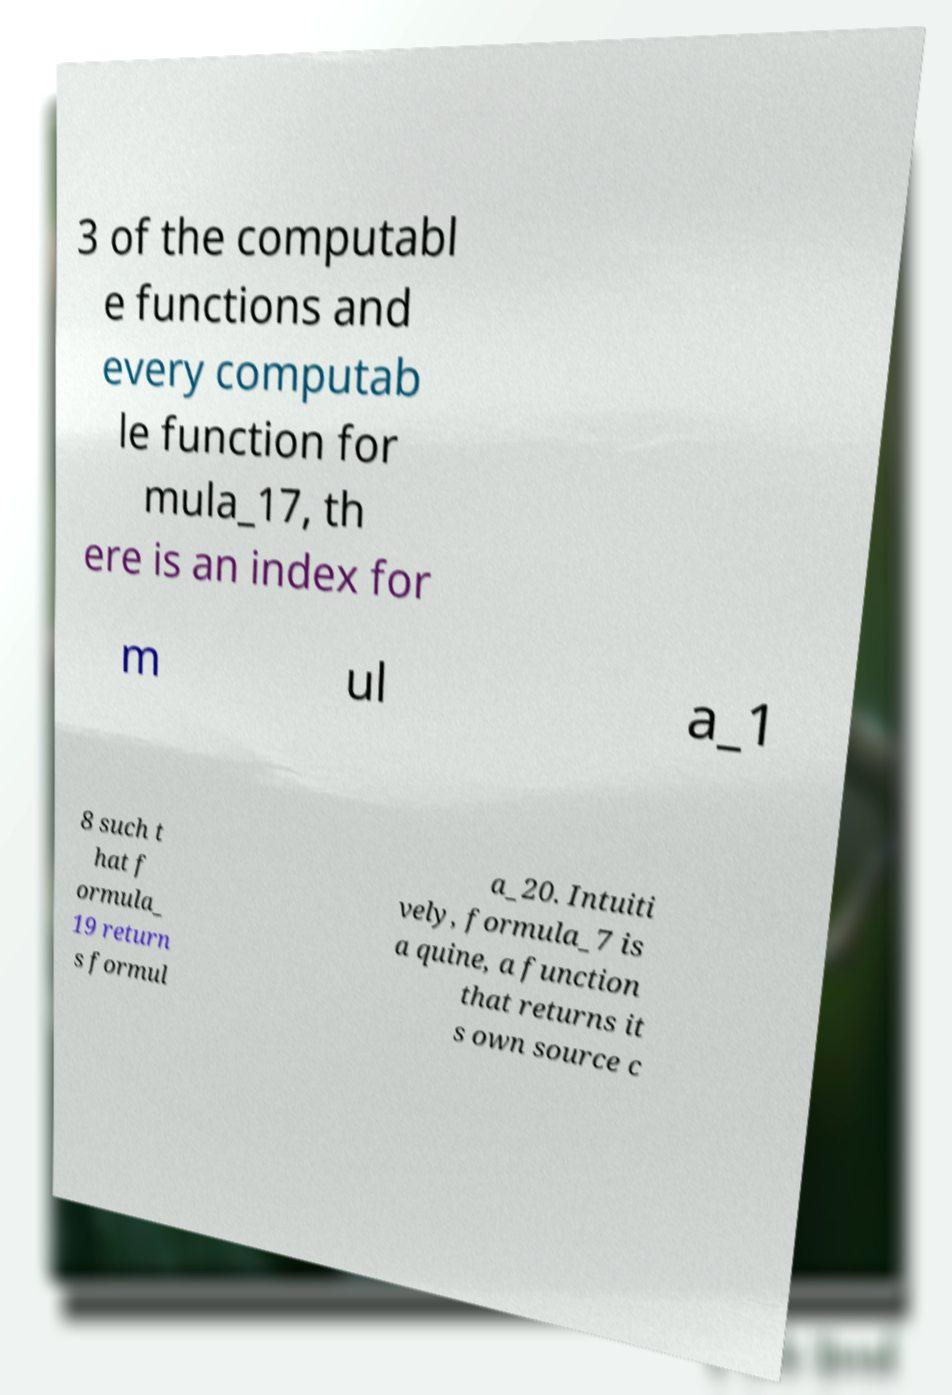Can you accurately transcribe the text from the provided image for me? 3 of the computabl e functions and every computab le function for mula_17, th ere is an index for m ul a_1 8 such t hat f ormula_ 19 return s formul a_20. Intuiti vely, formula_7 is a quine, a function that returns it s own source c 